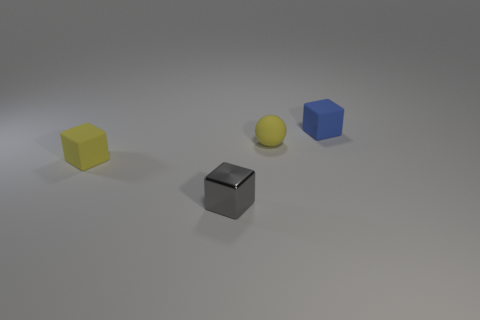How many rubber objects have the same color as the small sphere?
Offer a terse response. 1. How many other objects are the same size as the blue cube?
Give a very brief answer. 3. What is the material of the gray thing that is the same shape as the blue rubber thing?
Offer a very short reply. Metal. The tiny yellow thing right of the tiny matte block to the left of the small object that is right of the small matte sphere is made of what material?
Your response must be concise. Rubber. There is a sphere that is made of the same material as the small yellow cube; what is its size?
Offer a very short reply. Small. Are there any other things of the same color as the shiny object?
Offer a very short reply. No. There is a matte cube that is in front of the blue rubber object; is it the same color as the small cube on the right side of the gray metallic cube?
Your response must be concise. No. The rubber cube left of the tiny metal block is what color?
Offer a terse response. Yellow. There is a rubber block in front of the blue block; does it have the same size as the gray metallic block?
Give a very brief answer. Yes. Is the number of gray blocks less than the number of cyan cylinders?
Your answer should be compact. No. 